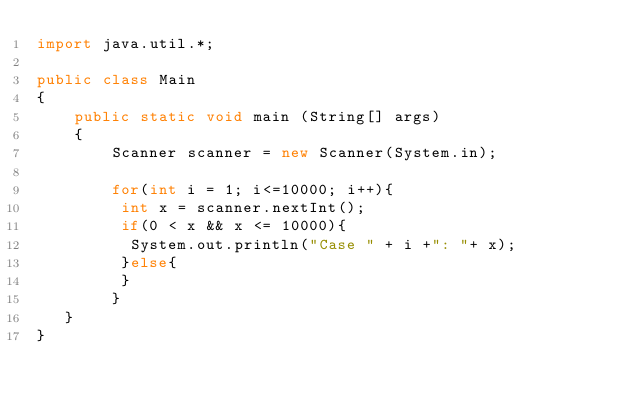Convert code to text. <code><loc_0><loc_0><loc_500><loc_500><_Java_>import java.util.*;
      
public class Main
{
    public static void main (String[] args)
    {
        Scanner scanner = new Scanner(System.in);
      
        for(int i = 1; i<=10000; i++){
         int x = scanner.nextInt();
         if(0 < x && x <= 10000){
          System.out.println("Case " + i +": "+ x);
         }else{
         }
        }
   }
}</code> 